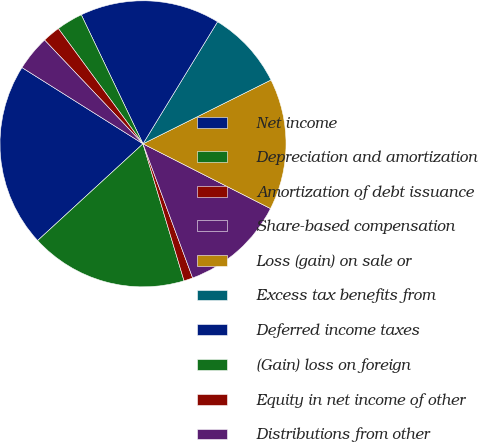<chart> <loc_0><loc_0><loc_500><loc_500><pie_chart><fcel>Net income<fcel>Depreciation and amortization<fcel>Amortization of debt issuance<fcel>Share-based compensation<fcel>Loss (gain) on sale or<fcel>Excess tax benefits from<fcel>Deferred income taxes<fcel>(Gain) loss on foreign<fcel>Equity in net income of other<fcel>Distributions from other<nl><fcel>20.77%<fcel>17.81%<fcel>1.01%<fcel>11.88%<fcel>14.84%<fcel>8.91%<fcel>15.83%<fcel>2.98%<fcel>2.0%<fcel>3.97%<nl></chart> 